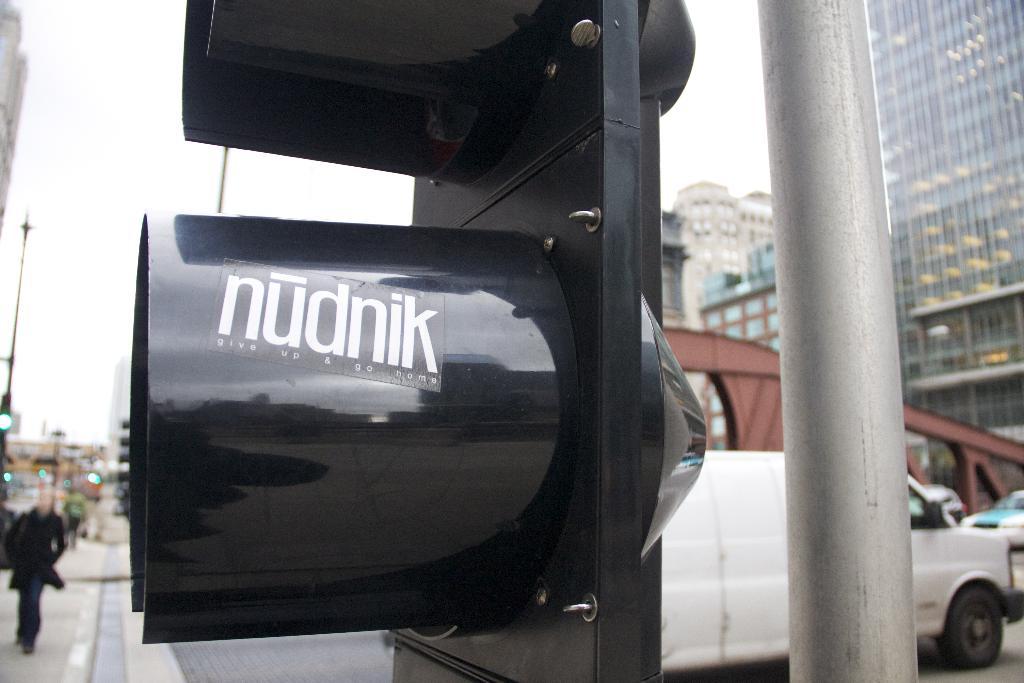Give up and go where according to this sticker?
Provide a short and direct response. Nudnik. 